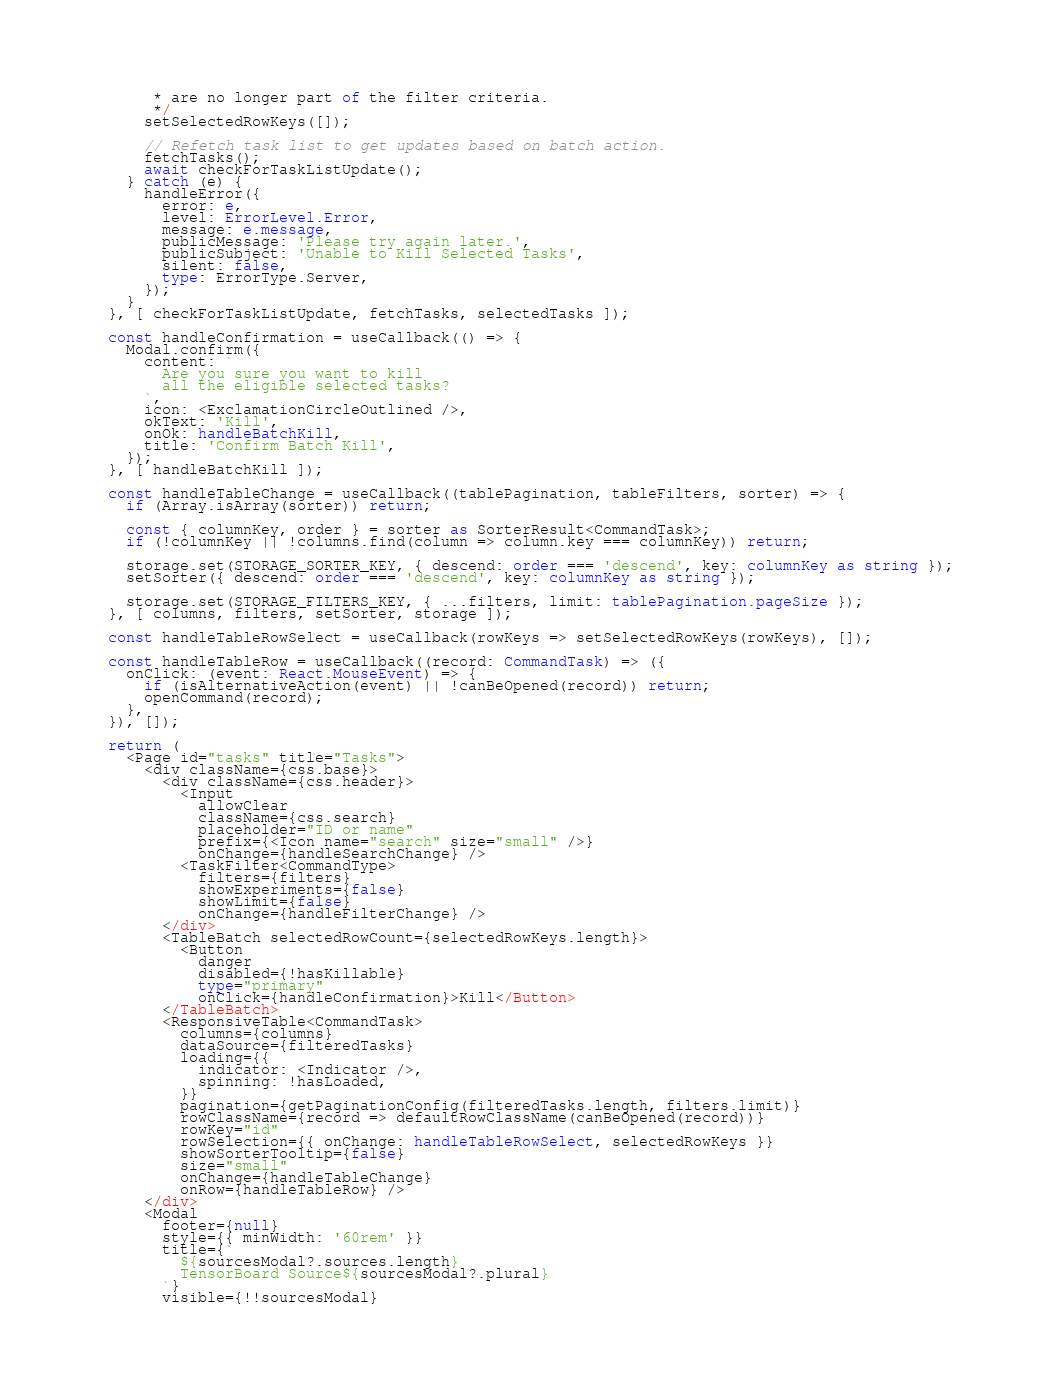<code> <loc_0><loc_0><loc_500><loc_500><_TypeScript_>       * are no longer part of the filter criteria.
       */
      setSelectedRowKeys([]);

      // Refetch task list to get updates based on batch action.
      fetchTasks();
      await checkForTaskListUpdate();
    } catch (e) {
      handleError({
        error: e,
        level: ErrorLevel.Error,
        message: e.message,
        publicMessage: 'Please try again later.',
        publicSubject: 'Unable to Kill Selected Tasks',
        silent: false,
        type: ErrorType.Server,
      });
    }
  }, [ checkForTaskListUpdate, fetchTasks, selectedTasks ]);

  const handleConfirmation = useCallback(() => {
    Modal.confirm({
      content: `
        Are you sure you want to kill
        all the eligible selected tasks?
      `,
      icon: <ExclamationCircleOutlined />,
      okText: 'Kill',
      onOk: handleBatchKill,
      title: 'Confirm Batch Kill',
    });
  }, [ handleBatchKill ]);

  const handleTableChange = useCallback((tablePagination, tableFilters, sorter) => {
    if (Array.isArray(sorter)) return;

    const { columnKey, order } = sorter as SorterResult<CommandTask>;
    if (!columnKey || !columns.find(column => column.key === columnKey)) return;

    storage.set(STORAGE_SORTER_KEY, { descend: order === 'descend', key: columnKey as string });
    setSorter({ descend: order === 'descend', key: columnKey as string });

    storage.set(STORAGE_FILTERS_KEY, { ...filters, limit: tablePagination.pageSize });
  }, [ columns, filters, setSorter, storage ]);

  const handleTableRowSelect = useCallback(rowKeys => setSelectedRowKeys(rowKeys), []);

  const handleTableRow = useCallback((record: CommandTask) => ({
    onClick: (event: React.MouseEvent) => {
      if (isAlternativeAction(event) || !canBeOpened(record)) return;
      openCommand(record);
    },
  }), []);

  return (
    <Page id="tasks" title="Tasks">
      <div className={css.base}>
        <div className={css.header}>
          <Input
            allowClear
            className={css.search}
            placeholder="ID or name"
            prefix={<Icon name="search" size="small" />}
            onChange={handleSearchChange} />
          <TaskFilter<CommandType>
            filters={filters}
            showExperiments={false}
            showLimit={false}
            onChange={handleFilterChange} />
        </div>
        <TableBatch selectedRowCount={selectedRowKeys.length}>
          <Button
            danger
            disabled={!hasKillable}
            type="primary"
            onClick={handleConfirmation}>Kill</Button>
        </TableBatch>
        <ResponsiveTable<CommandTask>
          columns={columns}
          dataSource={filteredTasks}
          loading={{
            indicator: <Indicator />,
            spinning: !hasLoaded,
          }}
          pagination={getPaginationConfig(filteredTasks.length, filters.limit)}
          rowClassName={record => defaultRowClassName(canBeOpened(record))}
          rowKey="id"
          rowSelection={{ onChange: handleTableRowSelect, selectedRowKeys }}
          showSorterTooltip={false}
          size="small"
          onChange={handleTableChange}
          onRow={handleTableRow} />
      </div>
      <Modal
        footer={null}
        style={{ minWidth: '60rem' }}
        title={`
          ${sourcesModal?.sources.length}
          TensorBoard Source${sourcesModal?.plural}
        `}
        visible={!!sourcesModal}</code> 